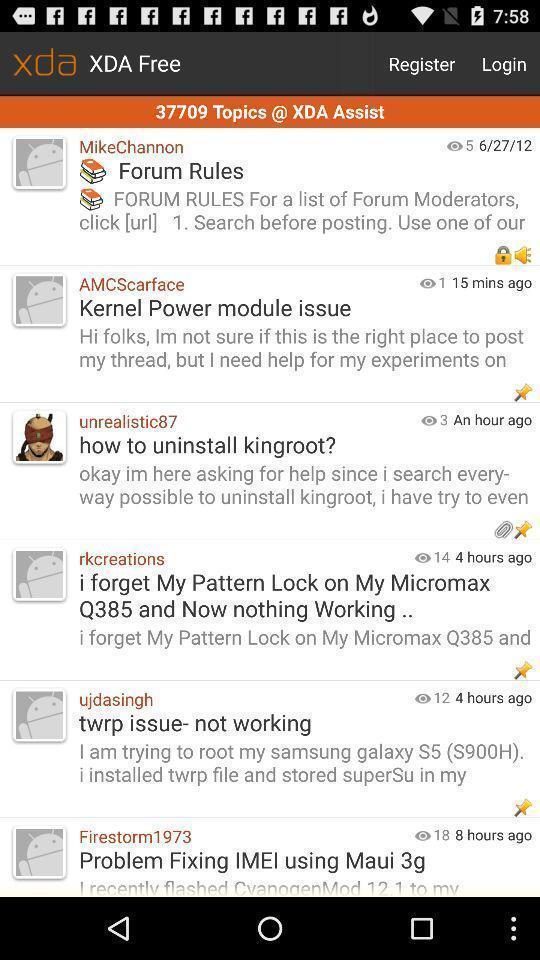Describe this image in words. Page displaying with list of different queries. 